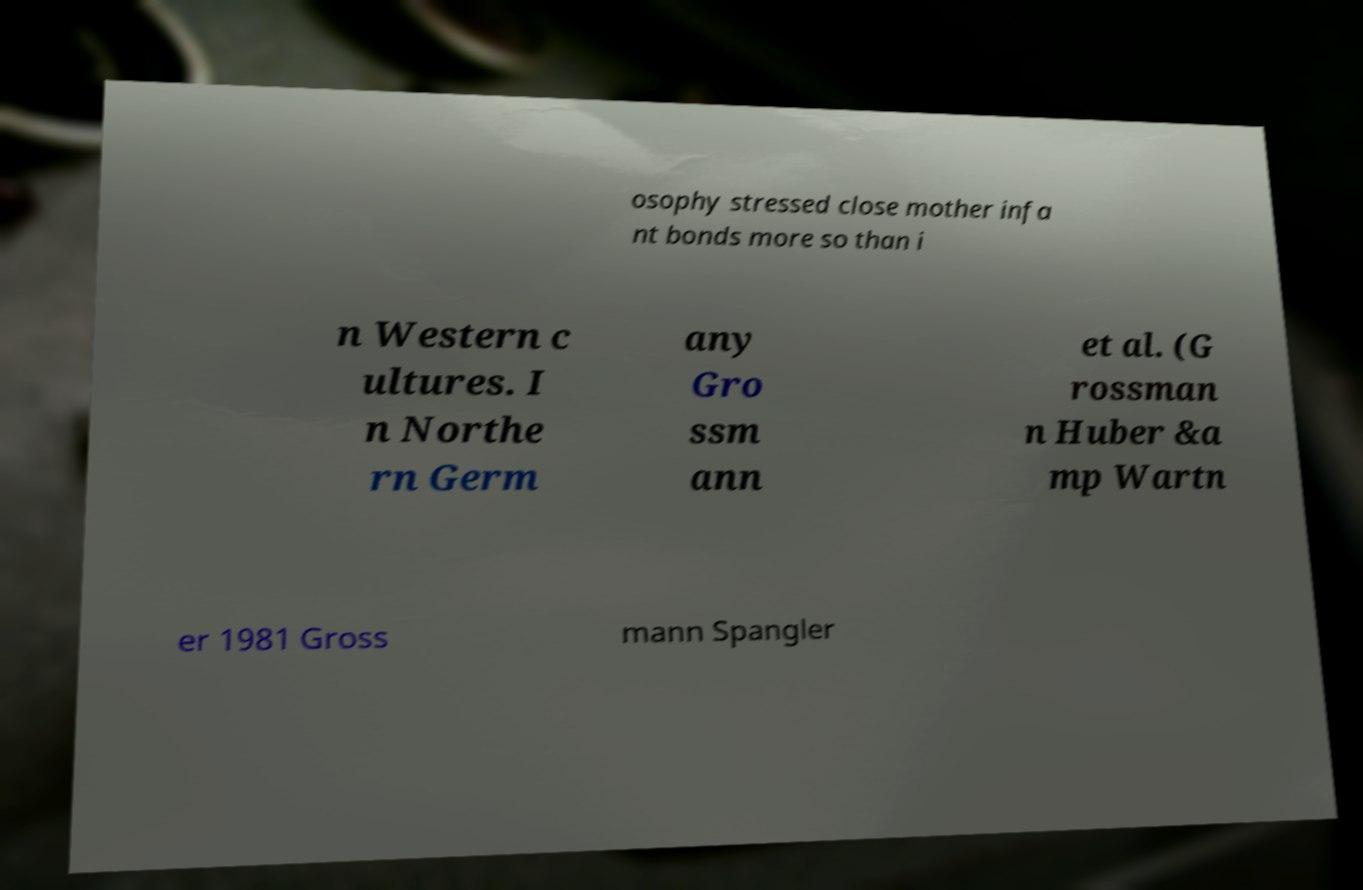Could you extract and type out the text from this image? osophy stressed close mother infa nt bonds more so than i n Western c ultures. I n Northe rn Germ any Gro ssm ann et al. (G rossman n Huber &a mp Wartn er 1981 Gross mann Spangler 